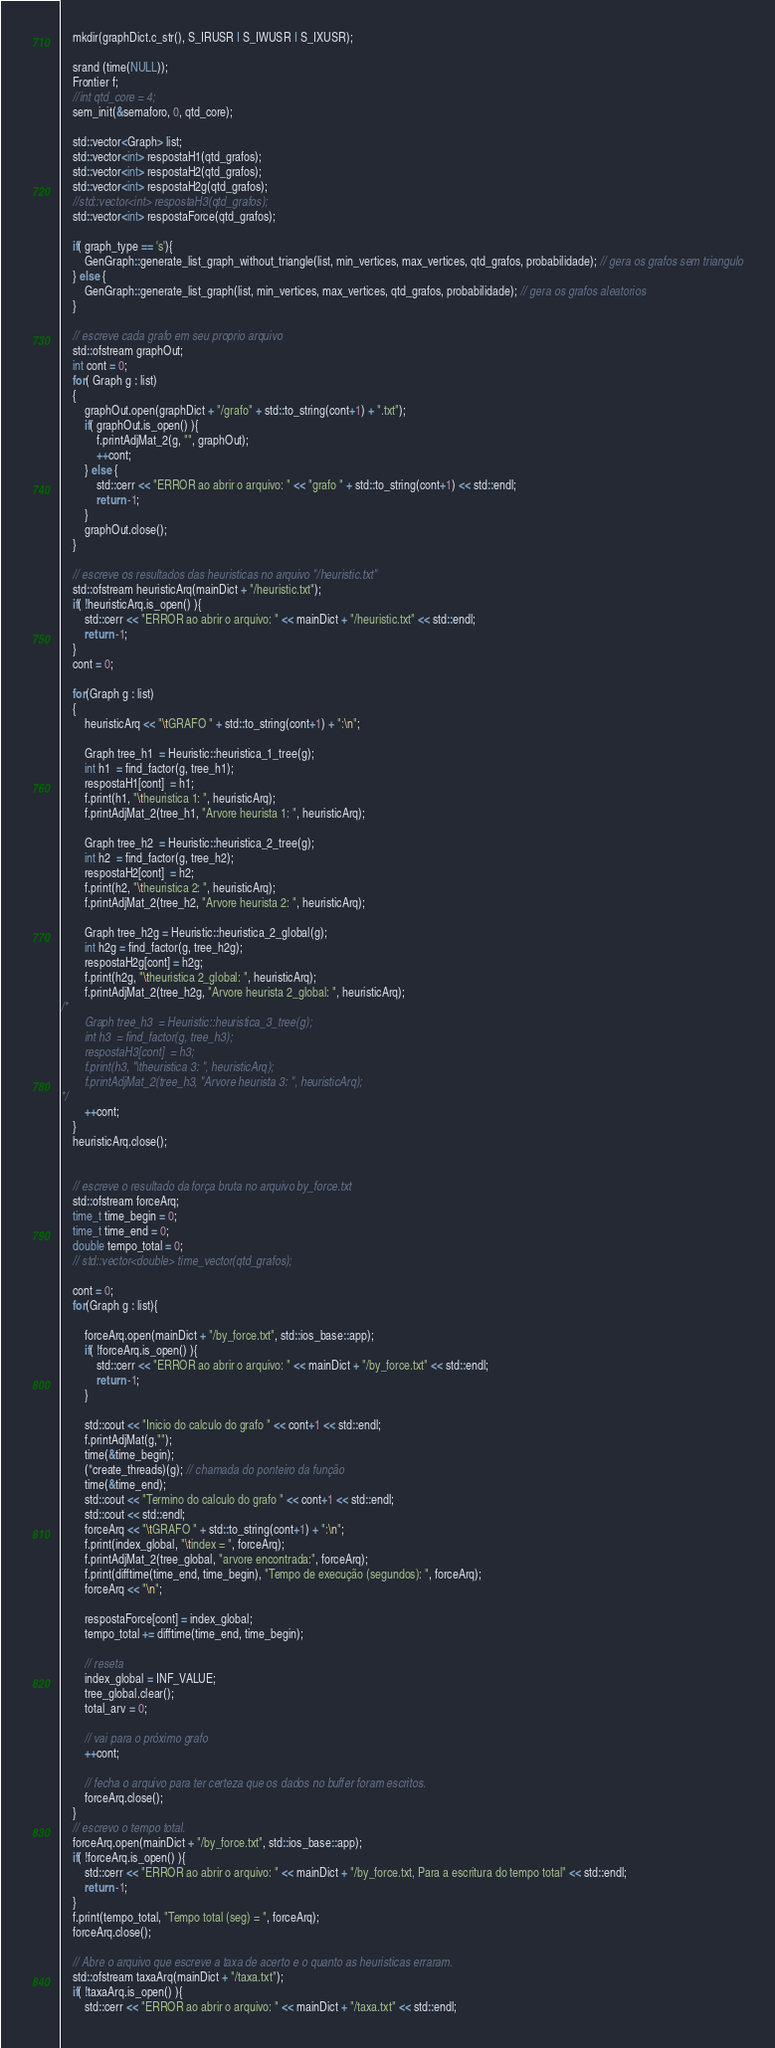Convert code to text. <code><loc_0><loc_0><loc_500><loc_500><_C++_>    mkdir(graphDict.c_str(), S_IRUSR | S_IWUSR | S_IXUSR);

    srand (time(NULL));
    Frontier f;
    //int qtd_core = 4;
    sem_init(&semaforo, 0, qtd_core);

    std::vector<Graph> list;
    std::vector<int> respostaH1(qtd_grafos);
    std::vector<int> respostaH2(qtd_grafos);
    std::vector<int> respostaH2g(qtd_grafos);
    //std::vector<int> respostaH3(qtd_grafos);
    std::vector<int> respostaForce(qtd_grafos);

    if( graph_type == 's'){
        GenGraph::generate_list_graph_without_triangle(list, min_vertices, max_vertices, qtd_grafos, probabilidade); // gera os grafos sem triangulo
    } else {
        GenGraph::generate_list_graph(list, min_vertices, max_vertices, qtd_grafos, probabilidade); // gera os grafos aleatorios
    }

    // escreve cada grafo em seu proprio arquivo
    std::ofstream graphOut;
    int cont = 0;
    for( Graph g : list)
    {
        graphOut.open(graphDict + "/grafo" + std::to_string(cont+1) + ".txt");
        if( graphOut.is_open() ){
            f.printAdjMat_2(g, "", graphOut);
            ++cont;
        } else {
            std::cerr << "ERROR ao abrir o arquivo: " << "grafo " + std::to_string(cont+1) << std::endl;
            return -1;
        }
        graphOut.close();
    }
    
    // escreve os resultados das heuristicas no arquivo "/heuristic.txt"
    std::ofstream heuristicArq(mainDict + "/heuristic.txt");
    if( !heuristicArq.is_open() ){
        std::cerr << "ERROR ao abrir o arquivo: " << mainDict + "/heuristic.txt" << std::endl;
        return -1;
    }
    cont = 0;
    
    for(Graph g : list)
    {
        heuristicArq << "\tGRAFO " + std::to_string(cont+1) + ":\n";

        Graph tree_h1  = Heuristic::heuristica_1_tree(g);
        int h1  = find_factor(g, tree_h1);
        respostaH1[cont]  = h1;
        f.print(h1, "\theuristica 1: ", heuristicArq);
        f.printAdjMat_2(tree_h1, "Arvore heurista 1: ", heuristicArq);

        Graph tree_h2  = Heuristic::heuristica_2_tree(g);
        int h2  = find_factor(g, tree_h2);
        respostaH2[cont]  = h2;
        f.print(h2, "\theuristica 2: ", heuristicArq);
        f.printAdjMat_2(tree_h2, "Arvore heurista 2: ", heuristicArq);

        Graph tree_h2g = Heuristic::heuristica_2_global(g);
        int h2g = find_factor(g, tree_h2g);
        respostaH2g[cont] = h2g;
        f.print(h2g, "\theuristica 2_global: ", heuristicArq);
        f.printAdjMat_2(tree_h2g, "Arvore heurista 2_global: ", heuristicArq);
/*
        Graph tree_h3  = Heuristic::heuristica_3_tree(g);
        int h3  = find_factor(g, tree_h3);
        respostaH3[cont]  = h3;
        f.print(h3, "\theuristica 3: ", heuristicArq);
        f.printAdjMat_2(tree_h3, "Arvore heurista 3: ", heuristicArq);
*/        
        ++cont;
    }
    heuristicArq.close();
    

    // escreve o resultado da força bruta no arquivo by_force.txt
    std::ofstream forceArq;
    time_t time_begin = 0;
    time_t time_end = 0;
    double tempo_total = 0;
    // std::vector<double> time_vector(qtd_grafos);

    cont = 0;
    for(Graph g : list){

        forceArq.open(mainDict + "/by_force.txt", std::ios_base::app);
        if( !forceArq.is_open() ){
            std::cerr << "ERROR ao abrir o arquivo: " << mainDict + "/by_force.txt" << std::endl;
            return -1;
        }
        
        std::cout << "Inicio do calculo do grafo " << cont+1 << std::endl;
        f.printAdjMat(g,"");
        time(&time_begin);
        (*create_threads)(g); // chamada do ponteiro da função
        time(&time_end);
        std::cout << "Termino do calculo do grafo " << cont+1 << std::endl;
        std::cout << std::endl;
        forceArq << "\tGRAFO " + std::to_string(cont+1) + ":\n";
        f.print(index_global, "\tindex = ", forceArq);
        f.printAdjMat_2(tree_global, "arvore encontrada:", forceArq);
        f.print(difftime(time_end, time_begin), "Tempo de execução (segundos): ", forceArq);
        forceArq << "\n";

        respostaForce[cont] = index_global;
        tempo_total += difftime(time_end, time_begin);
        
        // reseta 
        index_global = INF_VALUE;
        tree_global.clear();
        total_arv = 0;

        // vai para o próximo grafo
        ++cont;

        // fecha o arquivo para ter certeza que os dados no buffer foram escritos.
        forceArq.close();
    }
    // escrevo o tempo total.
    forceArq.open(mainDict + "/by_force.txt", std::ios_base::app);
    if( !forceArq.is_open() ){
        std::cerr << "ERROR ao abrir o arquivo: " << mainDict + "/by_force.txt, Para a escritura do tempo total" << std::endl;
        return -1;
    }
    f.print(tempo_total, "Tempo total (seg) = ", forceArq);
    forceArq.close();

    // Abre o arquivo que escreve a taxa de acerto e o quanto as heuristicas erraram.
    std::ofstream taxaArq(mainDict + "/taxa.txt");
    if( !taxaArq.is_open() ){
        std::cerr << "ERROR ao abrir o arquivo: " << mainDict + "/taxa.txt" << std::endl;</code> 